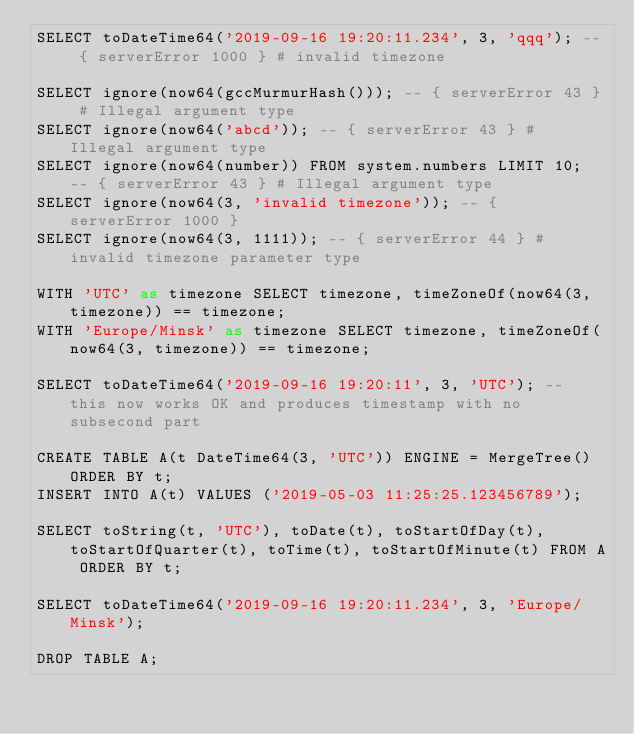<code> <loc_0><loc_0><loc_500><loc_500><_SQL_>SELECT toDateTime64('2019-09-16 19:20:11.234', 3, 'qqq'); -- { serverError 1000 } # invalid timezone

SELECT ignore(now64(gccMurmurHash())); -- { serverError 43 } # Illegal argument type
SELECT ignore(now64('abcd')); -- { serverError 43 } # Illegal argument type
SELECT ignore(now64(number)) FROM system.numbers LIMIT 10; -- { serverError 43 } # Illegal argument type
SELECT ignore(now64(3, 'invalid timezone')); -- { serverError 1000 }
SELECT ignore(now64(3, 1111)); -- { serverError 44 } # invalid timezone parameter type

WITH 'UTC' as timezone SELECT timezone, timeZoneOf(now64(3, timezone)) == timezone;
WITH 'Europe/Minsk' as timezone SELECT timezone, timeZoneOf(now64(3, timezone)) == timezone;

SELECT toDateTime64('2019-09-16 19:20:11', 3, 'UTC'); -- this now works OK and produces timestamp with no subsecond part

CREATE TABLE A(t DateTime64(3, 'UTC')) ENGINE = MergeTree() ORDER BY t;
INSERT INTO A(t) VALUES ('2019-05-03 11:25:25.123456789');

SELECT toString(t, 'UTC'), toDate(t), toStartOfDay(t), toStartOfQuarter(t), toTime(t), toStartOfMinute(t) FROM A ORDER BY t;

SELECT toDateTime64('2019-09-16 19:20:11.234', 3, 'Europe/Minsk');

DROP TABLE A;
</code> 